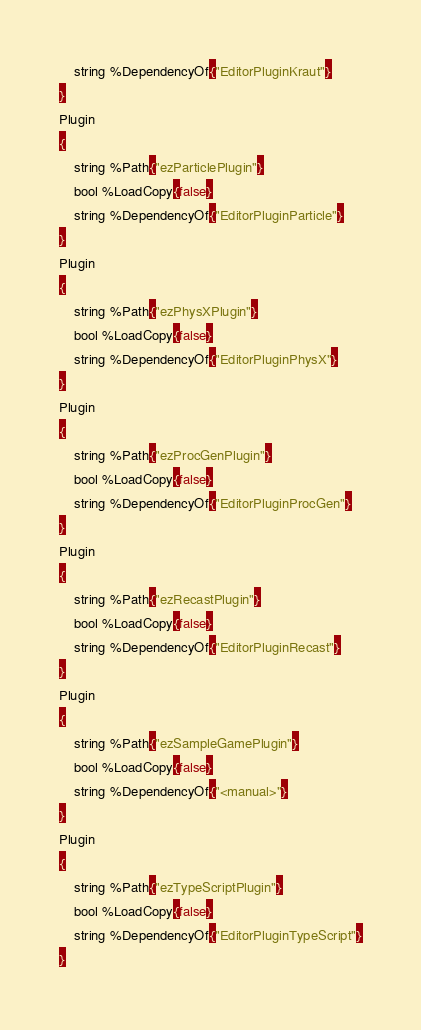Convert code to text. <code><loc_0><loc_0><loc_500><loc_500><_SQL_>	string %DependencyOf{"EditorPluginKraut"}
}
Plugin
{
	string %Path{"ezParticlePlugin"}
	bool %LoadCopy{false}
	string %DependencyOf{"EditorPluginParticle"}
}
Plugin
{
	string %Path{"ezPhysXPlugin"}
	bool %LoadCopy{false}
	string %DependencyOf{"EditorPluginPhysX"}
}
Plugin
{
	string %Path{"ezProcGenPlugin"}
	bool %LoadCopy{false}
	string %DependencyOf{"EditorPluginProcGen"}
}
Plugin
{
	string %Path{"ezRecastPlugin"}
	bool %LoadCopy{false}
	string %DependencyOf{"EditorPluginRecast"}
}
Plugin
{
	string %Path{"ezSampleGamePlugin"}
	bool %LoadCopy{false}
	string %DependencyOf{"<manual>"}
}
Plugin
{
	string %Path{"ezTypeScriptPlugin"}
	bool %LoadCopy{false}
	string %DependencyOf{"EditorPluginTypeScript"}
}
</code> 